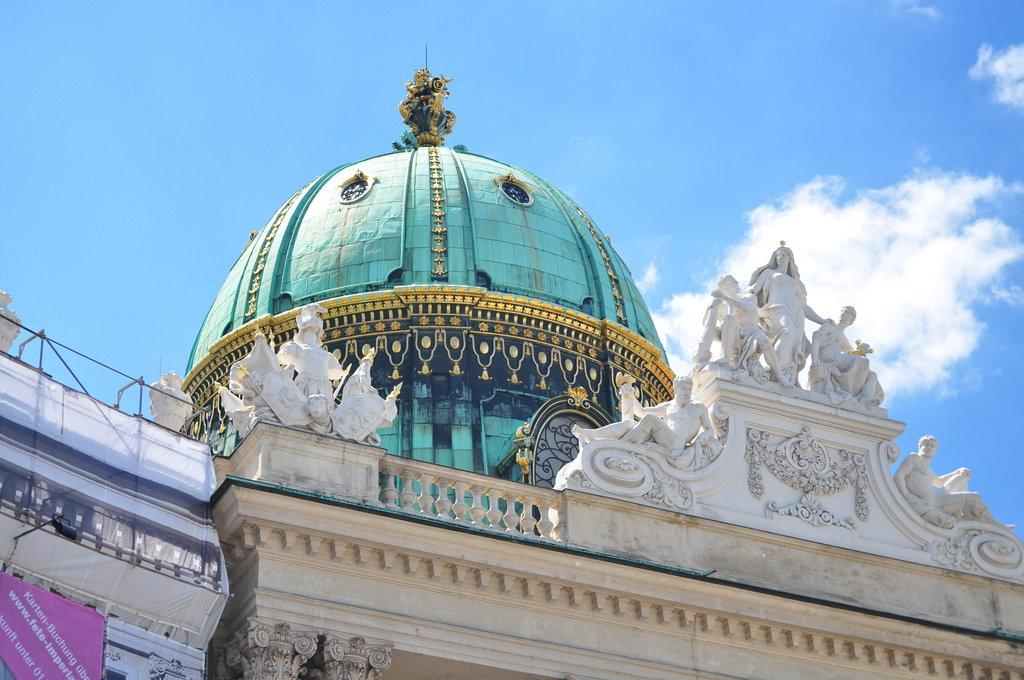What type of decorations can be seen on the building in the image? There are sculptures on the building in the image. What architectural feature is present on the building? There is a dome-like structure on the building. Can you describe the main subject of the image? The building is visible in the image. What is visible behind the building? The sky is visible behind the building. What color crayon is used to draw the authority figure in the image? There is no crayon or authority figure present in the image; it features a building with sculptures and a dome-like structure. 